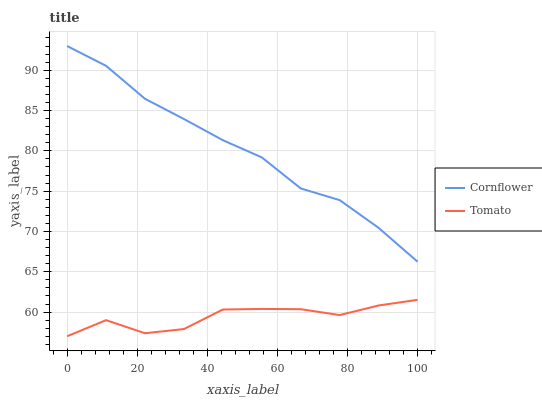Does Tomato have the minimum area under the curve?
Answer yes or no. Yes. Does Cornflower have the maximum area under the curve?
Answer yes or no. Yes. Does Cornflower have the minimum area under the curve?
Answer yes or no. No. Is Cornflower the smoothest?
Answer yes or no. Yes. Is Tomato the roughest?
Answer yes or no. Yes. Is Cornflower the roughest?
Answer yes or no. No. Does Tomato have the lowest value?
Answer yes or no. Yes. Does Cornflower have the lowest value?
Answer yes or no. No. Does Cornflower have the highest value?
Answer yes or no. Yes. Is Tomato less than Cornflower?
Answer yes or no. Yes. Is Cornflower greater than Tomato?
Answer yes or no. Yes. Does Tomato intersect Cornflower?
Answer yes or no. No. 